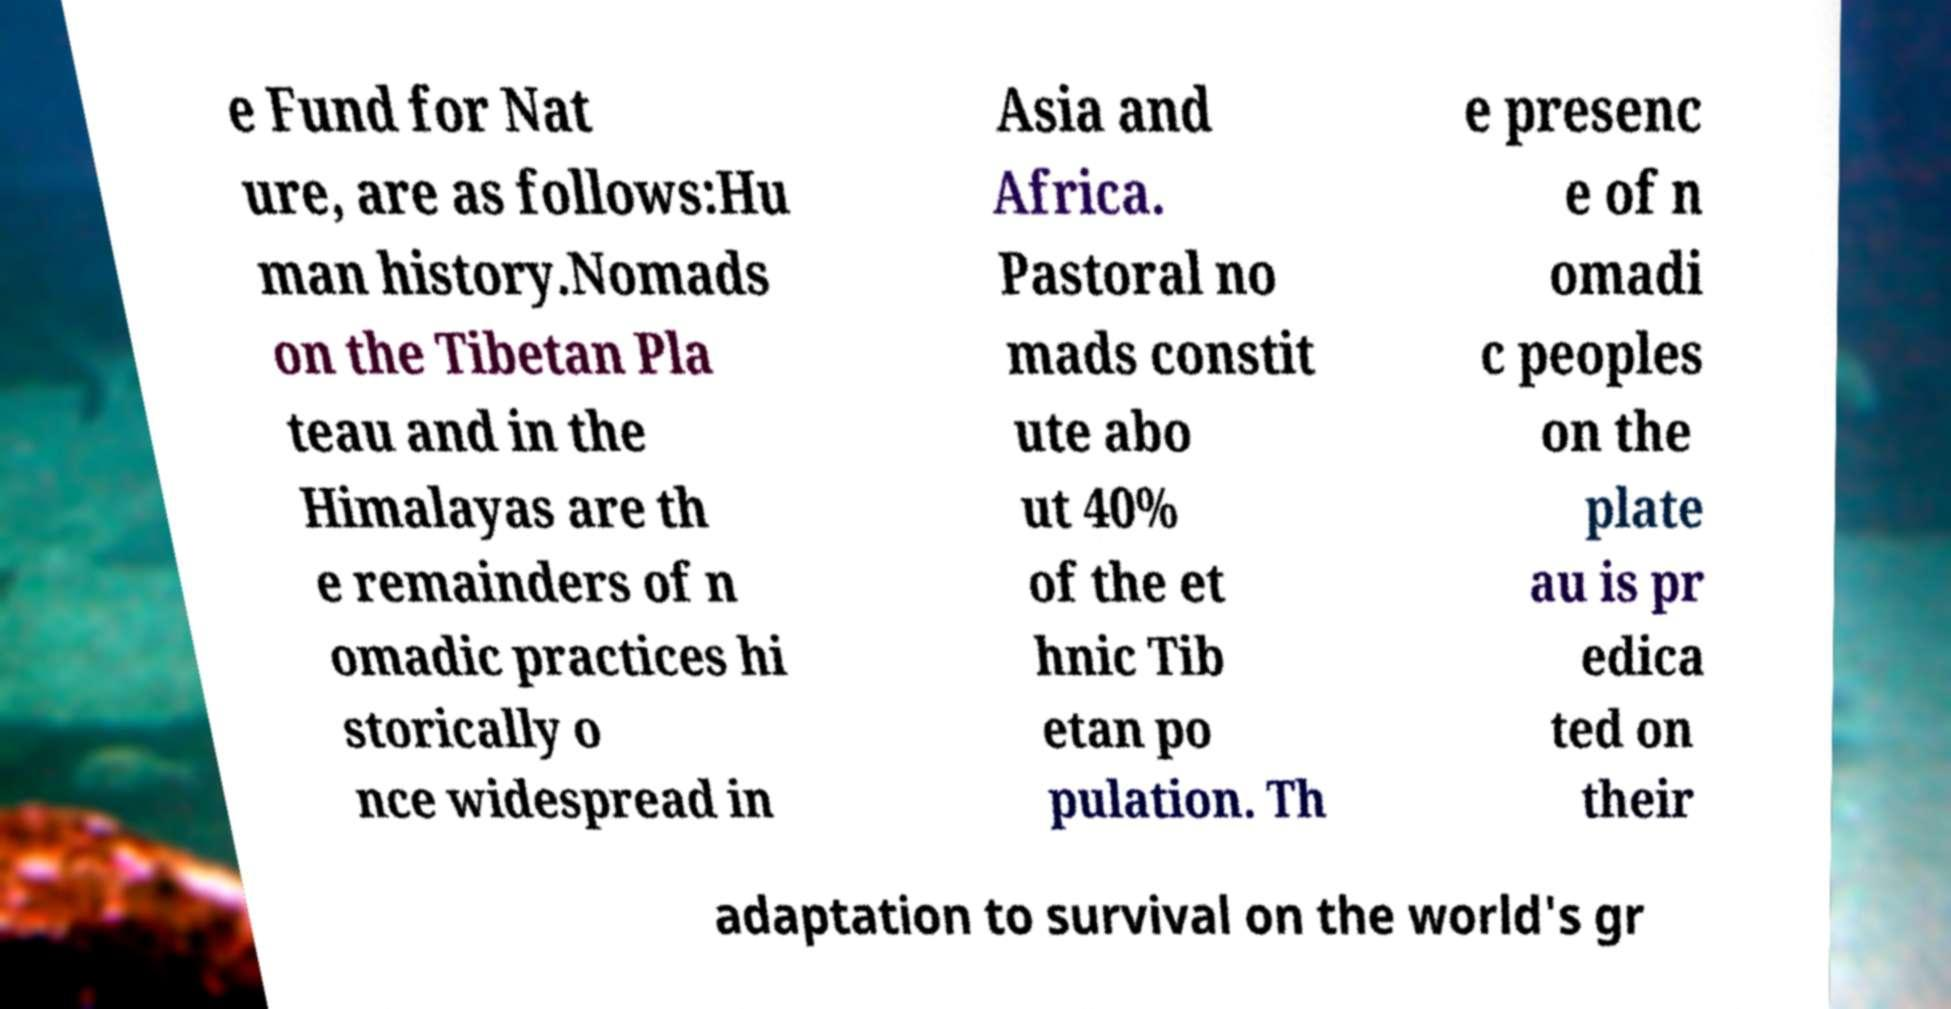Can you read and provide the text displayed in the image?This photo seems to have some interesting text. Can you extract and type it out for me? e Fund for Nat ure, are as follows:Hu man history.Nomads on the Tibetan Pla teau and in the Himalayas are th e remainders of n omadic practices hi storically o nce widespread in Asia and Africa. Pastoral no mads constit ute abo ut 40% of the et hnic Tib etan po pulation. Th e presenc e of n omadi c peoples on the plate au is pr edica ted on their adaptation to survival on the world's gr 